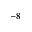<formula> <loc_0><loc_0><loc_500><loc_500>^ { - 8 }</formula> 